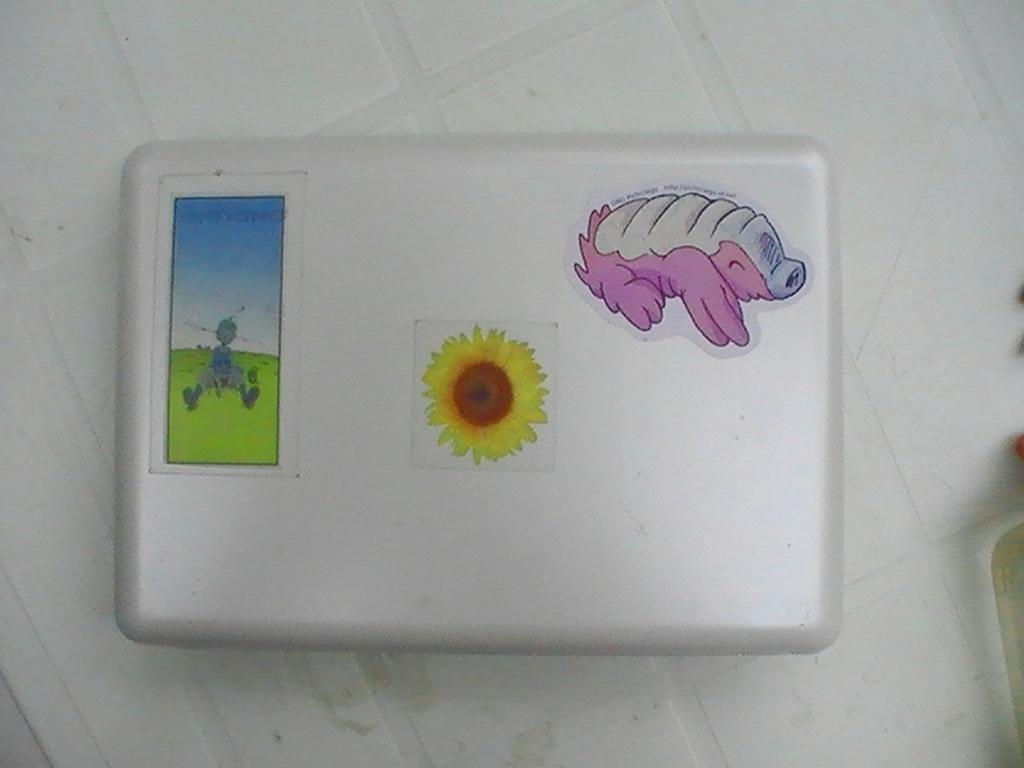What is the color of the box in the image? The box is white in color. Are there any markings or labels on the box? Yes, the box has three stickers on it. Where is the box located in the image? The box is placed on the floor. What type of apples are being comfortably discussed in the image? There are no apples or discussions present in the image; it only features a white color box with three stickers on it. 